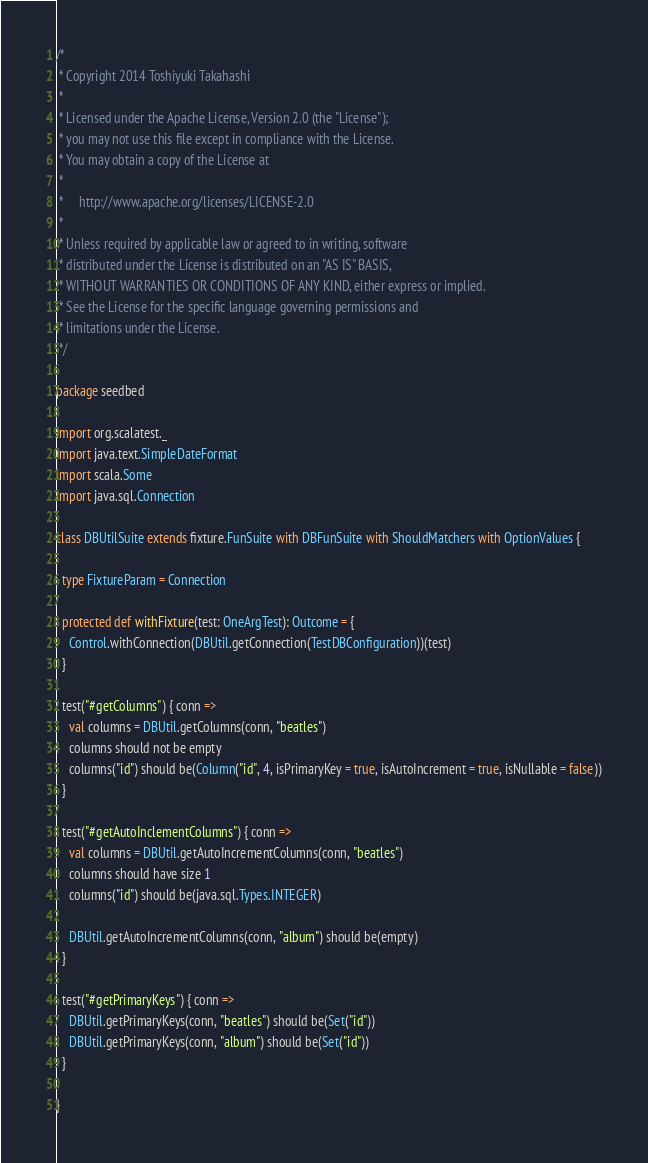Convert code to text. <code><loc_0><loc_0><loc_500><loc_500><_Scala_>/*
 * Copyright 2014 Toshiyuki Takahashi
 *
 * Licensed under the Apache License, Version 2.0 (the "License");
 * you may not use this file except in compliance with the License.
 * You may obtain a copy of the License at
 *
 *     http://www.apache.org/licenses/LICENSE-2.0
 *
 * Unless required by applicable law or agreed to in writing, software
 * distributed under the License is distributed on an "AS IS" BASIS,
 * WITHOUT WARRANTIES OR CONDITIONS OF ANY KIND, either express or implied.
 * See the License for the specific language governing permissions and
 * limitations under the License.
 */

package seedbed

import org.scalatest._
import java.text.SimpleDateFormat
import scala.Some
import java.sql.Connection

class DBUtilSuite extends fixture.FunSuite with DBFunSuite with ShouldMatchers with OptionValues {

  type FixtureParam = Connection

  protected def withFixture(test: OneArgTest): Outcome = {
    Control.withConnection(DBUtil.getConnection(TestDBConfiguration))(test)
  }

  test("#getColumns") { conn =>
    val columns = DBUtil.getColumns(conn, "beatles")
    columns should not be empty
    columns("id") should be(Column("id", 4, isPrimaryKey = true, isAutoIncrement = true, isNullable = false))
  }

  test("#getAutoInclementColumns") { conn =>
    val columns = DBUtil.getAutoIncrementColumns(conn, "beatles")
    columns should have size 1
    columns("id") should be(java.sql.Types.INTEGER)

    DBUtil.getAutoIncrementColumns(conn, "album") should be(empty)
  }

  test("#getPrimaryKeys") { conn =>
    DBUtil.getPrimaryKeys(conn, "beatles") should be(Set("id"))
    DBUtil.getPrimaryKeys(conn, "album") should be(Set("id"))
  }

}

</code> 